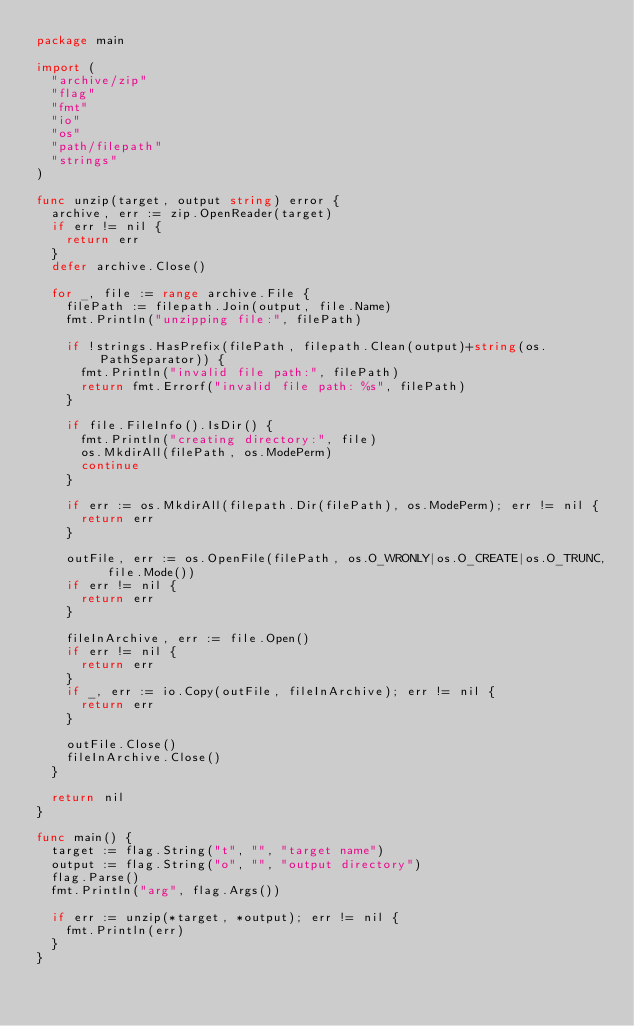Convert code to text. <code><loc_0><loc_0><loc_500><loc_500><_Go_>package main

import (
	"archive/zip"
	"flag"
	"fmt"
	"io"
	"os"
	"path/filepath"
	"strings"
)

func unzip(target, output string) error {
	archive, err := zip.OpenReader(target)
	if err != nil {
		return err
	}
	defer archive.Close()

	for _, file := range archive.File {
		filePath := filepath.Join(output, file.Name)
		fmt.Println("unzipping file:", filePath)

		if !strings.HasPrefix(filePath, filepath.Clean(output)+string(os.PathSeparator)) {
			fmt.Println("invalid file path:", filePath)
			return fmt.Errorf("invalid file path: %s", filePath)
		}

		if file.FileInfo().IsDir() {
			fmt.Println("creating directory:", file)
			os.MkdirAll(filePath, os.ModePerm)
			continue
		}

		if err := os.MkdirAll(filepath.Dir(filePath), os.ModePerm); err != nil {
			return err
		}

		outFile, err := os.OpenFile(filePath, os.O_WRONLY|os.O_CREATE|os.O_TRUNC, file.Mode())
		if err != nil {
			return err
		}

		fileInArchive, err := file.Open()
		if err != nil {
			return err
		}
		if _, err := io.Copy(outFile, fileInArchive); err != nil {
			return err
		}

		outFile.Close()
		fileInArchive.Close()
	}

	return nil
}

func main() {
	target := flag.String("t", "", "target name")
	output := flag.String("o", "", "output directory")
	flag.Parse()
	fmt.Println("arg", flag.Args())

	if err := unzip(*target, *output); err != nil {
		fmt.Println(err)
	}
}
</code> 